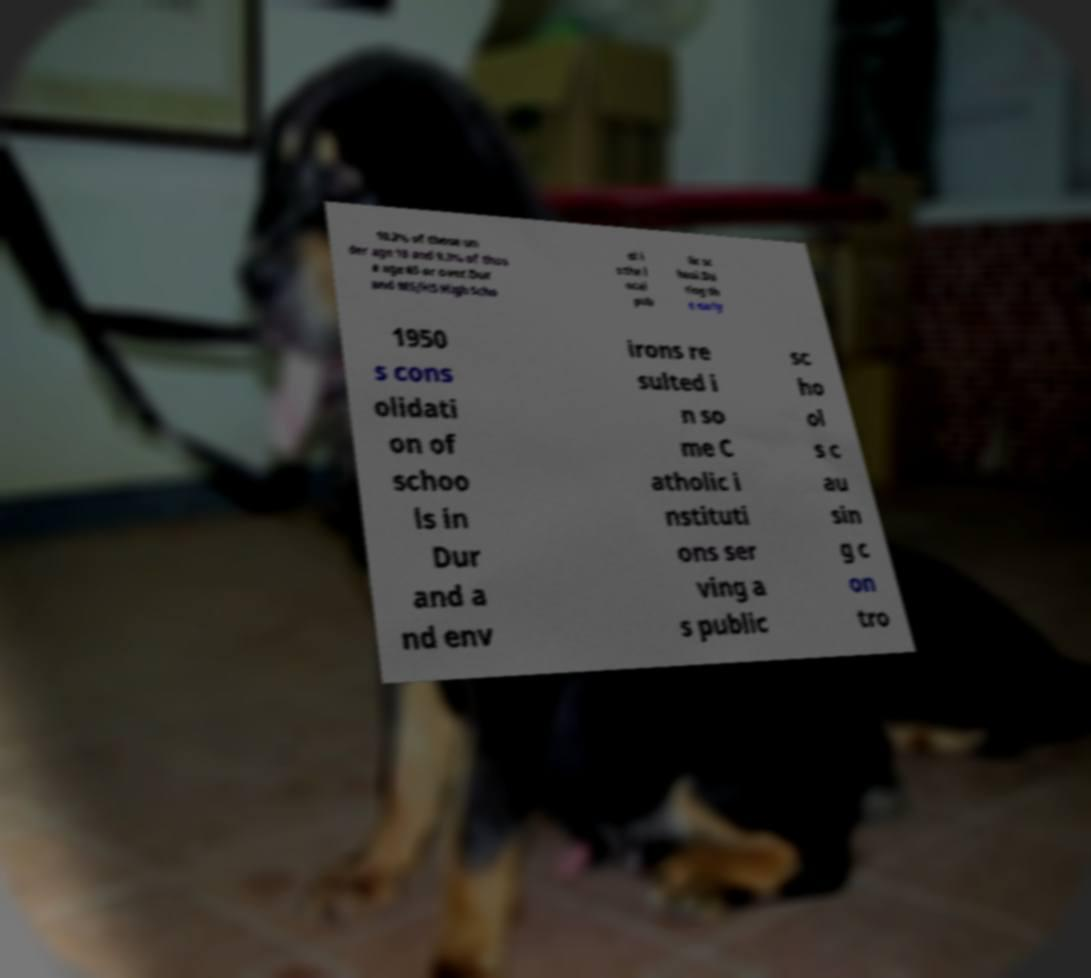Could you assist in decoding the text presented in this image and type it out clearly? 10.2% of those un der age 18 and 9.3% of thos e age 65 or over.Dur and MS/HS High Scho ol i s the l ocal pub lic sc hool.Du ring th e early 1950 s cons olidati on of schoo ls in Dur and a nd env irons re sulted i n so me C atholic i nstituti ons ser ving a s public sc ho ol s c au sin g c on tro 